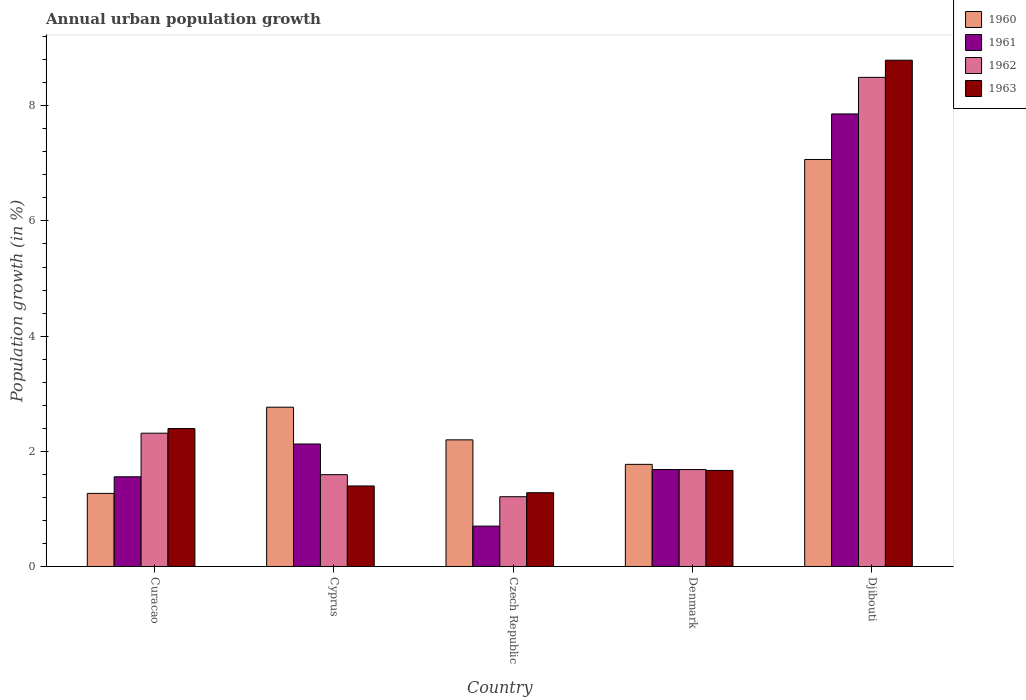How many different coloured bars are there?
Your response must be concise. 4. How many groups of bars are there?
Give a very brief answer. 5. Are the number of bars on each tick of the X-axis equal?
Offer a very short reply. Yes. How many bars are there on the 1st tick from the left?
Your answer should be compact. 4. What is the label of the 3rd group of bars from the left?
Make the answer very short. Czech Republic. In how many cases, is the number of bars for a given country not equal to the number of legend labels?
Offer a very short reply. 0. What is the percentage of urban population growth in 1960 in Curacao?
Your answer should be compact. 1.27. Across all countries, what is the maximum percentage of urban population growth in 1962?
Offer a terse response. 8.49. Across all countries, what is the minimum percentage of urban population growth in 1960?
Offer a very short reply. 1.27. In which country was the percentage of urban population growth in 1961 maximum?
Your answer should be compact. Djibouti. In which country was the percentage of urban population growth in 1963 minimum?
Make the answer very short. Czech Republic. What is the total percentage of urban population growth in 1963 in the graph?
Offer a very short reply. 15.53. What is the difference between the percentage of urban population growth in 1960 in Curacao and that in Cyprus?
Ensure brevity in your answer.  -1.5. What is the difference between the percentage of urban population growth in 1960 in Djibouti and the percentage of urban population growth in 1961 in Curacao?
Your answer should be compact. 5.51. What is the average percentage of urban population growth in 1962 per country?
Provide a succinct answer. 3.06. What is the difference between the percentage of urban population growth of/in 1961 and percentage of urban population growth of/in 1962 in Cyprus?
Your response must be concise. 0.53. What is the ratio of the percentage of urban population growth in 1960 in Curacao to that in Djibouti?
Make the answer very short. 0.18. Is the percentage of urban population growth in 1961 in Curacao less than that in Denmark?
Give a very brief answer. Yes. Is the difference between the percentage of urban population growth in 1961 in Czech Republic and Djibouti greater than the difference between the percentage of urban population growth in 1962 in Czech Republic and Djibouti?
Your response must be concise. Yes. What is the difference between the highest and the second highest percentage of urban population growth in 1963?
Your answer should be compact. 7.12. What is the difference between the highest and the lowest percentage of urban population growth in 1963?
Keep it short and to the point. 7.51. What does the 3rd bar from the right in Czech Republic represents?
Offer a terse response. 1961. What is the difference between two consecutive major ticks on the Y-axis?
Provide a short and direct response. 2. Are the values on the major ticks of Y-axis written in scientific E-notation?
Provide a short and direct response. No. Does the graph contain any zero values?
Your answer should be compact. No. Does the graph contain grids?
Offer a very short reply. No. Where does the legend appear in the graph?
Give a very brief answer. Top right. How are the legend labels stacked?
Your response must be concise. Vertical. What is the title of the graph?
Your response must be concise. Annual urban population growth. What is the label or title of the X-axis?
Provide a succinct answer. Country. What is the label or title of the Y-axis?
Your response must be concise. Population growth (in %). What is the Population growth (in %) in 1960 in Curacao?
Make the answer very short. 1.27. What is the Population growth (in %) of 1961 in Curacao?
Provide a short and direct response. 1.56. What is the Population growth (in %) in 1962 in Curacao?
Provide a short and direct response. 2.31. What is the Population growth (in %) in 1963 in Curacao?
Offer a very short reply. 2.4. What is the Population growth (in %) in 1960 in Cyprus?
Offer a very short reply. 2.77. What is the Population growth (in %) of 1961 in Cyprus?
Give a very brief answer. 2.13. What is the Population growth (in %) of 1962 in Cyprus?
Give a very brief answer. 1.59. What is the Population growth (in %) of 1963 in Cyprus?
Offer a very short reply. 1.4. What is the Population growth (in %) of 1960 in Czech Republic?
Give a very brief answer. 2.2. What is the Population growth (in %) of 1961 in Czech Republic?
Provide a short and direct response. 0.7. What is the Population growth (in %) in 1962 in Czech Republic?
Ensure brevity in your answer.  1.21. What is the Population growth (in %) of 1963 in Czech Republic?
Offer a terse response. 1.28. What is the Population growth (in %) of 1960 in Denmark?
Offer a very short reply. 1.77. What is the Population growth (in %) in 1961 in Denmark?
Make the answer very short. 1.68. What is the Population growth (in %) in 1962 in Denmark?
Ensure brevity in your answer.  1.68. What is the Population growth (in %) in 1963 in Denmark?
Make the answer very short. 1.67. What is the Population growth (in %) in 1960 in Djibouti?
Your answer should be compact. 7.07. What is the Population growth (in %) in 1961 in Djibouti?
Make the answer very short. 7.86. What is the Population growth (in %) of 1962 in Djibouti?
Give a very brief answer. 8.49. What is the Population growth (in %) of 1963 in Djibouti?
Keep it short and to the point. 8.79. Across all countries, what is the maximum Population growth (in %) in 1960?
Keep it short and to the point. 7.07. Across all countries, what is the maximum Population growth (in %) in 1961?
Offer a terse response. 7.86. Across all countries, what is the maximum Population growth (in %) of 1962?
Provide a succinct answer. 8.49. Across all countries, what is the maximum Population growth (in %) in 1963?
Your answer should be compact. 8.79. Across all countries, what is the minimum Population growth (in %) in 1960?
Provide a succinct answer. 1.27. Across all countries, what is the minimum Population growth (in %) of 1961?
Your response must be concise. 0.7. Across all countries, what is the minimum Population growth (in %) in 1962?
Keep it short and to the point. 1.21. Across all countries, what is the minimum Population growth (in %) in 1963?
Make the answer very short. 1.28. What is the total Population growth (in %) of 1960 in the graph?
Provide a short and direct response. 15.07. What is the total Population growth (in %) in 1961 in the graph?
Offer a terse response. 13.93. What is the total Population growth (in %) of 1962 in the graph?
Keep it short and to the point. 15.3. What is the total Population growth (in %) of 1963 in the graph?
Your response must be concise. 15.53. What is the difference between the Population growth (in %) in 1960 in Curacao and that in Cyprus?
Make the answer very short. -1.5. What is the difference between the Population growth (in %) of 1961 in Curacao and that in Cyprus?
Your answer should be very brief. -0.57. What is the difference between the Population growth (in %) of 1962 in Curacao and that in Cyprus?
Your response must be concise. 0.72. What is the difference between the Population growth (in %) in 1963 in Curacao and that in Cyprus?
Ensure brevity in your answer.  1. What is the difference between the Population growth (in %) of 1960 in Curacao and that in Czech Republic?
Your answer should be very brief. -0.93. What is the difference between the Population growth (in %) of 1961 in Curacao and that in Czech Republic?
Ensure brevity in your answer.  0.86. What is the difference between the Population growth (in %) of 1962 in Curacao and that in Czech Republic?
Make the answer very short. 1.1. What is the difference between the Population growth (in %) of 1963 in Curacao and that in Czech Republic?
Make the answer very short. 1.11. What is the difference between the Population growth (in %) in 1960 in Curacao and that in Denmark?
Give a very brief answer. -0.5. What is the difference between the Population growth (in %) in 1961 in Curacao and that in Denmark?
Your response must be concise. -0.13. What is the difference between the Population growth (in %) of 1962 in Curacao and that in Denmark?
Make the answer very short. 0.63. What is the difference between the Population growth (in %) of 1963 in Curacao and that in Denmark?
Provide a succinct answer. 0.73. What is the difference between the Population growth (in %) in 1960 in Curacao and that in Djibouti?
Offer a terse response. -5.8. What is the difference between the Population growth (in %) in 1961 in Curacao and that in Djibouti?
Give a very brief answer. -6.3. What is the difference between the Population growth (in %) of 1962 in Curacao and that in Djibouti?
Ensure brevity in your answer.  -6.18. What is the difference between the Population growth (in %) in 1963 in Curacao and that in Djibouti?
Your response must be concise. -6.4. What is the difference between the Population growth (in %) of 1960 in Cyprus and that in Czech Republic?
Keep it short and to the point. 0.57. What is the difference between the Population growth (in %) in 1961 in Cyprus and that in Czech Republic?
Provide a short and direct response. 1.43. What is the difference between the Population growth (in %) in 1962 in Cyprus and that in Czech Republic?
Keep it short and to the point. 0.38. What is the difference between the Population growth (in %) in 1963 in Cyprus and that in Czech Republic?
Make the answer very short. 0.12. What is the difference between the Population growth (in %) of 1961 in Cyprus and that in Denmark?
Give a very brief answer. 0.44. What is the difference between the Population growth (in %) of 1962 in Cyprus and that in Denmark?
Keep it short and to the point. -0.09. What is the difference between the Population growth (in %) in 1963 in Cyprus and that in Denmark?
Make the answer very short. -0.27. What is the difference between the Population growth (in %) in 1960 in Cyprus and that in Djibouti?
Provide a short and direct response. -4.3. What is the difference between the Population growth (in %) in 1961 in Cyprus and that in Djibouti?
Provide a short and direct response. -5.73. What is the difference between the Population growth (in %) of 1962 in Cyprus and that in Djibouti?
Make the answer very short. -6.9. What is the difference between the Population growth (in %) of 1963 in Cyprus and that in Djibouti?
Your response must be concise. -7.39. What is the difference between the Population growth (in %) in 1960 in Czech Republic and that in Denmark?
Make the answer very short. 0.43. What is the difference between the Population growth (in %) of 1961 in Czech Republic and that in Denmark?
Provide a short and direct response. -0.98. What is the difference between the Population growth (in %) of 1962 in Czech Republic and that in Denmark?
Provide a succinct answer. -0.47. What is the difference between the Population growth (in %) of 1963 in Czech Republic and that in Denmark?
Offer a terse response. -0.39. What is the difference between the Population growth (in %) of 1960 in Czech Republic and that in Djibouti?
Give a very brief answer. -4.87. What is the difference between the Population growth (in %) in 1961 in Czech Republic and that in Djibouti?
Provide a succinct answer. -7.16. What is the difference between the Population growth (in %) in 1962 in Czech Republic and that in Djibouti?
Keep it short and to the point. -7.28. What is the difference between the Population growth (in %) of 1963 in Czech Republic and that in Djibouti?
Your response must be concise. -7.51. What is the difference between the Population growth (in %) in 1960 in Denmark and that in Djibouti?
Provide a short and direct response. -5.29. What is the difference between the Population growth (in %) of 1961 in Denmark and that in Djibouti?
Keep it short and to the point. -6.17. What is the difference between the Population growth (in %) in 1962 in Denmark and that in Djibouti?
Offer a terse response. -6.81. What is the difference between the Population growth (in %) in 1963 in Denmark and that in Djibouti?
Your answer should be compact. -7.12. What is the difference between the Population growth (in %) of 1960 in Curacao and the Population growth (in %) of 1961 in Cyprus?
Ensure brevity in your answer.  -0.86. What is the difference between the Population growth (in %) of 1960 in Curacao and the Population growth (in %) of 1962 in Cyprus?
Keep it short and to the point. -0.33. What is the difference between the Population growth (in %) in 1960 in Curacao and the Population growth (in %) in 1963 in Cyprus?
Your answer should be very brief. -0.13. What is the difference between the Population growth (in %) in 1961 in Curacao and the Population growth (in %) in 1962 in Cyprus?
Offer a terse response. -0.04. What is the difference between the Population growth (in %) in 1961 in Curacao and the Population growth (in %) in 1963 in Cyprus?
Offer a terse response. 0.16. What is the difference between the Population growth (in %) in 1962 in Curacao and the Population growth (in %) in 1963 in Cyprus?
Offer a very short reply. 0.92. What is the difference between the Population growth (in %) in 1960 in Curacao and the Population growth (in %) in 1961 in Czech Republic?
Offer a very short reply. 0.57. What is the difference between the Population growth (in %) of 1960 in Curacao and the Population growth (in %) of 1962 in Czech Republic?
Provide a short and direct response. 0.06. What is the difference between the Population growth (in %) of 1960 in Curacao and the Population growth (in %) of 1963 in Czech Republic?
Your answer should be very brief. -0.01. What is the difference between the Population growth (in %) of 1961 in Curacao and the Population growth (in %) of 1962 in Czech Republic?
Make the answer very short. 0.35. What is the difference between the Population growth (in %) of 1961 in Curacao and the Population growth (in %) of 1963 in Czech Republic?
Give a very brief answer. 0.28. What is the difference between the Population growth (in %) in 1962 in Curacao and the Population growth (in %) in 1963 in Czech Republic?
Ensure brevity in your answer.  1.03. What is the difference between the Population growth (in %) in 1960 in Curacao and the Population growth (in %) in 1961 in Denmark?
Your answer should be very brief. -0.41. What is the difference between the Population growth (in %) in 1960 in Curacao and the Population growth (in %) in 1962 in Denmark?
Your answer should be very brief. -0.41. What is the difference between the Population growth (in %) in 1960 in Curacao and the Population growth (in %) in 1963 in Denmark?
Offer a terse response. -0.4. What is the difference between the Population growth (in %) in 1961 in Curacao and the Population growth (in %) in 1962 in Denmark?
Give a very brief answer. -0.13. What is the difference between the Population growth (in %) of 1961 in Curacao and the Population growth (in %) of 1963 in Denmark?
Offer a terse response. -0.11. What is the difference between the Population growth (in %) of 1962 in Curacao and the Population growth (in %) of 1963 in Denmark?
Your answer should be compact. 0.65. What is the difference between the Population growth (in %) in 1960 in Curacao and the Population growth (in %) in 1961 in Djibouti?
Ensure brevity in your answer.  -6.59. What is the difference between the Population growth (in %) of 1960 in Curacao and the Population growth (in %) of 1962 in Djibouti?
Your response must be concise. -7.22. What is the difference between the Population growth (in %) in 1960 in Curacao and the Population growth (in %) in 1963 in Djibouti?
Provide a succinct answer. -7.52. What is the difference between the Population growth (in %) of 1961 in Curacao and the Population growth (in %) of 1962 in Djibouti?
Your answer should be compact. -6.94. What is the difference between the Population growth (in %) of 1961 in Curacao and the Population growth (in %) of 1963 in Djibouti?
Provide a short and direct response. -7.23. What is the difference between the Population growth (in %) in 1962 in Curacao and the Population growth (in %) in 1963 in Djibouti?
Your answer should be very brief. -6.48. What is the difference between the Population growth (in %) in 1960 in Cyprus and the Population growth (in %) in 1961 in Czech Republic?
Provide a succinct answer. 2.06. What is the difference between the Population growth (in %) in 1960 in Cyprus and the Population growth (in %) in 1962 in Czech Republic?
Ensure brevity in your answer.  1.55. What is the difference between the Population growth (in %) in 1960 in Cyprus and the Population growth (in %) in 1963 in Czech Republic?
Give a very brief answer. 1.48. What is the difference between the Population growth (in %) of 1961 in Cyprus and the Population growth (in %) of 1962 in Czech Republic?
Offer a very short reply. 0.92. What is the difference between the Population growth (in %) in 1961 in Cyprus and the Population growth (in %) in 1963 in Czech Republic?
Your answer should be compact. 0.85. What is the difference between the Population growth (in %) in 1962 in Cyprus and the Population growth (in %) in 1963 in Czech Republic?
Ensure brevity in your answer.  0.31. What is the difference between the Population growth (in %) of 1960 in Cyprus and the Population growth (in %) of 1961 in Denmark?
Keep it short and to the point. 1.08. What is the difference between the Population growth (in %) in 1960 in Cyprus and the Population growth (in %) in 1962 in Denmark?
Provide a succinct answer. 1.08. What is the difference between the Population growth (in %) in 1960 in Cyprus and the Population growth (in %) in 1963 in Denmark?
Ensure brevity in your answer.  1.1. What is the difference between the Population growth (in %) in 1961 in Cyprus and the Population growth (in %) in 1962 in Denmark?
Offer a very short reply. 0.44. What is the difference between the Population growth (in %) of 1961 in Cyprus and the Population growth (in %) of 1963 in Denmark?
Make the answer very short. 0.46. What is the difference between the Population growth (in %) in 1962 in Cyprus and the Population growth (in %) in 1963 in Denmark?
Give a very brief answer. -0.07. What is the difference between the Population growth (in %) in 1960 in Cyprus and the Population growth (in %) in 1961 in Djibouti?
Ensure brevity in your answer.  -5.09. What is the difference between the Population growth (in %) of 1960 in Cyprus and the Population growth (in %) of 1962 in Djibouti?
Ensure brevity in your answer.  -5.73. What is the difference between the Population growth (in %) in 1960 in Cyprus and the Population growth (in %) in 1963 in Djibouti?
Your answer should be compact. -6.03. What is the difference between the Population growth (in %) of 1961 in Cyprus and the Population growth (in %) of 1962 in Djibouti?
Your response must be concise. -6.37. What is the difference between the Population growth (in %) in 1961 in Cyprus and the Population growth (in %) in 1963 in Djibouti?
Your response must be concise. -6.66. What is the difference between the Population growth (in %) in 1962 in Cyprus and the Population growth (in %) in 1963 in Djibouti?
Your response must be concise. -7.2. What is the difference between the Population growth (in %) of 1960 in Czech Republic and the Population growth (in %) of 1961 in Denmark?
Give a very brief answer. 0.51. What is the difference between the Population growth (in %) of 1960 in Czech Republic and the Population growth (in %) of 1962 in Denmark?
Make the answer very short. 0.52. What is the difference between the Population growth (in %) of 1960 in Czech Republic and the Population growth (in %) of 1963 in Denmark?
Your response must be concise. 0.53. What is the difference between the Population growth (in %) of 1961 in Czech Republic and the Population growth (in %) of 1962 in Denmark?
Your answer should be very brief. -0.98. What is the difference between the Population growth (in %) of 1961 in Czech Republic and the Population growth (in %) of 1963 in Denmark?
Your answer should be very brief. -0.97. What is the difference between the Population growth (in %) in 1962 in Czech Republic and the Population growth (in %) in 1963 in Denmark?
Provide a short and direct response. -0.46. What is the difference between the Population growth (in %) in 1960 in Czech Republic and the Population growth (in %) in 1961 in Djibouti?
Make the answer very short. -5.66. What is the difference between the Population growth (in %) in 1960 in Czech Republic and the Population growth (in %) in 1962 in Djibouti?
Your response must be concise. -6.29. What is the difference between the Population growth (in %) of 1960 in Czech Republic and the Population growth (in %) of 1963 in Djibouti?
Offer a terse response. -6.59. What is the difference between the Population growth (in %) of 1961 in Czech Republic and the Population growth (in %) of 1962 in Djibouti?
Offer a very short reply. -7.79. What is the difference between the Population growth (in %) in 1961 in Czech Republic and the Population growth (in %) in 1963 in Djibouti?
Give a very brief answer. -8.09. What is the difference between the Population growth (in %) of 1962 in Czech Republic and the Population growth (in %) of 1963 in Djibouti?
Ensure brevity in your answer.  -7.58. What is the difference between the Population growth (in %) in 1960 in Denmark and the Population growth (in %) in 1961 in Djibouti?
Offer a terse response. -6.08. What is the difference between the Population growth (in %) of 1960 in Denmark and the Population growth (in %) of 1962 in Djibouti?
Keep it short and to the point. -6.72. What is the difference between the Population growth (in %) in 1960 in Denmark and the Population growth (in %) in 1963 in Djibouti?
Ensure brevity in your answer.  -7.02. What is the difference between the Population growth (in %) in 1961 in Denmark and the Population growth (in %) in 1962 in Djibouti?
Your response must be concise. -6.81. What is the difference between the Population growth (in %) in 1961 in Denmark and the Population growth (in %) in 1963 in Djibouti?
Give a very brief answer. -7.11. What is the difference between the Population growth (in %) of 1962 in Denmark and the Population growth (in %) of 1963 in Djibouti?
Your answer should be compact. -7.11. What is the average Population growth (in %) in 1960 per country?
Your response must be concise. 3.01. What is the average Population growth (in %) of 1961 per country?
Ensure brevity in your answer.  2.79. What is the average Population growth (in %) of 1962 per country?
Offer a very short reply. 3.06. What is the average Population growth (in %) of 1963 per country?
Ensure brevity in your answer.  3.11. What is the difference between the Population growth (in %) of 1960 and Population growth (in %) of 1961 in Curacao?
Provide a short and direct response. -0.29. What is the difference between the Population growth (in %) in 1960 and Population growth (in %) in 1962 in Curacao?
Offer a terse response. -1.05. What is the difference between the Population growth (in %) in 1960 and Population growth (in %) in 1963 in Curacao?
Your response must be concise. -1.13. What is the difference between the Population growth (in %) in 1961 and Population growth (in %) in 1962 in Curacao?
Make the answer very short. -0.76. What is the difference between the Population growth (in %) in 1961 and Population growth (in %) in 1963 in Curacao?
Your answer should be compact. -0.84. What is the difference between the Population growth (in %) of 1962 and Population growth (in %) of 1963 in Curacao?
Offer a very short reply. -0.08. What is the difference between the Population growth (in %) in 1960 and Population growth (in %) in 1961 in Cyprus?
Provide a short and direct response. 0.64. What is the difference between the Population growth (in %) of 1960 and Population growth (in %) of 1962 in Cyprus?
Ensure brevity in your answer.  1.17. What is the difference between the Population growth (in %) in 1960 and Population growth (in %) in 1963 in Cyprus?
Provide a succinct answer. 1.37. What is the difference between the Population growth (in %) of 1961 and Population growth (in %) of 1962 in Cyprus?
Your answer should be very brief. 0.53. What is the difference between the Population growth (in %) in 1961 and Population growth (in %) in 1963 in Cyprus?
Ensure brevity in your answer.  0.73. What is the difference between the Population growth (in %) of 1962 and Population growth (in %) of 1963 in Cyprus?
Provide a succinct answer. 0.2. What is the difference between the Population growth (in %) in 1960 and Population growth (in %) in 1961 in Czech Republic?
Provide a succinct answer. 1.5. What is the difference between the Population growth (in %) in 1960 and Population growth (in %) in 1962 in Czech Republic?
Your answer should be compact. 0.99. What is the difference between the Population growth (in %) of 1960 and Population growth (in %) of 1963 in Czech Republic?
Ensure brevity in your answer.  0.92. What is the difference between the Population growth (in %) of 1961 and Population growth (in %) of 1962 in Czech Republic?
Ensure brevity in your answer.  -0.51. What is the difference between the Population growth (in %) in 1961 and Population growth (in %) in 1963 in Czech Republic?
Your answer should be very brief. -0.58. What is the difference between the Population growth (in %) in 1962 and Population growth (in %) in 1963 in Czech Republic?
Provide a succinct answer. -0.07. What is the difference between the Population growth (in %) of 1960 and Population growth (in %) of 1961 in Denmark?
Make the answer very short. 0.09. What is the difference between the Population growth (in %) of 1960 and Population growth (in %) of 1962 in Denmark?
Your answer should be very brief. 0.09. What is the difference between the Population growth (in %) in 1960 and Population growth (in %) in 1963 in Denmark?
Keep it short and to the point. 0.11. What is the difference between the Population growth (in %) in 1961 and Population growth (in %) in 1962 in Denmark?
Keep it short and to the point. 0. What is the difference between the Population growth (in %) of 1961 and Population growth (in %) of 1963 in Denmark?
Offer a very short reply. 0.02. What is the difference between the Population growth (in %) in 1962 and Population growth (in %) in 1963 in Denmark?
Provide a succinct answer. 0.01. What is the difference between the Population growth (in %) of 1960 and Population growth (in %) of 1961 in Djibouti?
Offer a terse response. -0.79. What is the difference between the Population growth (in %) of 1960 and Population growth (in %) of 1962 in Djibouti?
Ensure brevity in your answer.  -1.43. What is the difference between the Population growth (in %) in 1960 and Population growth (in %) in 1963 in Djibouti?
Provide a succinct answer. -1.72. What is the difference between the Population growth (in %) of 1961 and Population growth (in %) of 1962 in Djibouti?
Keep it short and to the point. -0.63. What is the difference between the Population growth (in %) of 1961 and Population growth (in %) of 1963 in Djibouti?
Your answer should be very brief. -0.93. What is the difference between the Population growth (in %) of 1962 and Population growth (in %) of 1963 in Djibouti?
Your answer should be very brief. -0.3. What is the ratio of the Population growth (in %) of 1960 in Curacao to that in Cyprus?
Provide a succinct answer. 0.46. What is the ratio of the Population growth (in %) in 1961 in Curacao to that in Cyprus?
Make the answer very short. 0.73. What is the ratio of the Population growth (in %) in 1962 in Curacao to that in Cyprus?
Provide a succinct answer. 1.45. What is the ratio of the Population growth (in %) in 1963 in Curacao to that in Cyprus?
Provide a succinct answer. 1.71. What is the ratio of the Population growth (in %) in 1960 in Curacao to that in Czech Republic?
Ensure brevity in your answer.  0.58. What is the ratio of the Population growth (in %) of 1961 in Curacao to that in Czech Republic?
Keep it short and to the point. 2.22. What is the ratio of the Population growth (in %) in 1962 in Curacao to that in Czech Republic?
Your response must be concise. 1.91. What is the ratio of the Population growth (in %) of 1963 in Curacao to that in Czech Republic?
Offer a terse response. 1.87. What is the ratio of the Population growth (in %) in 1960 in Curacao to that in Denmark?
Provide a succinct answer. 0.72. What is the ratio of the Population growth (in %) in 1961 in Curacao to that in Denmark?
Give a very brief answer. 0.93. What is the ratio of the Population growth (in %) of 1962 in Curacao to that in Denmark?
Ensure brevity in your answer.  1.38. What is the ratio of the Population growth (in %) in 1963 in Curacao to that in Denmark?
Provide a short and direct response. 1.44. What is the ratio of the Population growth (in %) of 1960 in Curacao to that in Djibouti?
Ensure brevity in your answer.  0.18. What is the ratio of the Population growth (in %) of 1961 in Curacao to that in Djibouti?
Ensure brevity in your answer.  0.2. What is the ratio of the Population growth (in %) in 1962 in Curacao to that in Djibouti?
Ensure brevity in your answer.  0.27. What is the ratio of the Population growth (in %) of 1963 in Curacao to that in Djibouti?
Provide a short and direct response. 0.27. What is the ratio of the Population growth (in %) of 1960 in Cyprus to that in Czech Republic?
Provide a succinct answer. 1.26. What is the ratio of the Population growth (in %) of 1961 in Cyprus to that in Czech Republic?
Your answer should be very brief. 3.03. What is the ratio of the Population growth (in %) of 1962 in Cyprus to that in Czech Republic?
Keep it short and to the point. 1.32. What is the ratio of the Population growth (in %) in 1963 in Cyprus to that in Czech Republic?
Provide a short and direct response. 1.09. What is the ratio of the Population growth (in %) of 1960 in Cyprus to that in Denmark?
Ensure brevity in your answer.  1.56. What is the ratio of the Population growth (in %) in 1961 in Cyprus to that in Denmark?
Offer a very short reply. 1.26. What is the ratio of the Population growth (in %) of 1963 in Cyprus to that in Denmark?
Ensure brevity in your answer.  0.84. What is the ratio of the Population growth (in %) in 1960 in Cyprus to that in Djibouti?
Ensure brevity in your answer.  0.39. What is the ratio of the Population growth (in %) in 1961 in Cyprus to that in Djibouti?
Your answer should be very brief. 0.27. What is the ratio of the Population growth (in %) of 1962 in Cyprus to that in Djibouti?
Your answer should be very brief. 0.19. What is the ratio of the Population growth (in %) of 1963 in Cyprus to that in Djibouti?
Offer a terse response. 0.16. What is the ratio of the Population growth (in %) in 1960 in Czech Republic to that in Denmark?
Give a very brief answer. 1.24. What is the ratio of the Population growth (in %) of 1961 in Czech Republic to that in Denmark?
Provide a short and direct response. 0.42. What is the ratio of the Population growth (in %) of 1962 in Czech Republic to that in Denmark?
Give a very brief answer. 0.72. What is the ratio of the Population growth (in %) in 1963 in Czech Republic to that in Denmark?
Give a very brief answer. 0.77. What is the ratio of the Population growth (in %) in 1960 in Czech Republic to that in Djibouti?
Make the answer very short. 0.31. What is the ratio of the Population growth (in %) in 1961 in Czech Republic to that in Djibouti?
Provide a succinct answer. 0.09. What is the ratio of the Population growth (in %) of 1962 in Czech Republic to that in Djibouti?
Give a very brief answer. 0.14. What is the ratio of the Population growth (in %) of 1963 in Czech Republic to that in Djibouti?
Provide a succinct answer. 0.15. What is the ratio of the Population growth (in %) in 1960 in Denmark to that in Djibouti?
Offer a very short reply. 0.25. What is the ratio of the Population growth (in %) in 1961 in Denmark to that in Djibouti?
Your answer should be compact. 0.21. What is the ratio of the Population growth (in %) in 1962 in Denmark to that in Djibouti?
Ensure brevity in your answer.  0.2. What is the ratio of the Population growth (in %) in 1963 in Denmark to that in Djibouti?
Make the answer very short. 0.19. What is the difference between the highest and the second highest Population growth (in %) in 1960?
Provide a succinct answer. 4.3. What is the difference between the highest and the second highest Population growth (in %) in 1961?
Offer a terse response. 5.73. What is the difference between the highest and the second highest Population growth (in %) in 1962?
Make the answer very short. 6.18. What is the difference between the highest and the second highest Population growth (in %) in 1963?
Keep it short and to the point. 6.4. What is the difference between the highest and the lowest Population growth (in %) in 1960?
Offer a very short reply. 5.8. What is the difference between the highest and the lowest Population growth (in %) in 1961?
Make the answer very short. 7.16. What is the difference between the highest and the lowest Population growth (in %) in 1962?
Ensure brevity in your answer.  7.28. What is the difference between the highest and the lowest Population growth (in %) in 1963?
Give a very brief answer. 7.51. 